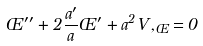<formula> <loc_0><loc_0><loc_500><loc_500>\phi ^ { \prime \prime } + 2 \frac { a ^ { \prime } } { a } \phi ^ { \prime } + a ^ { 2 } V , _ { \phi } = 0</formula> 